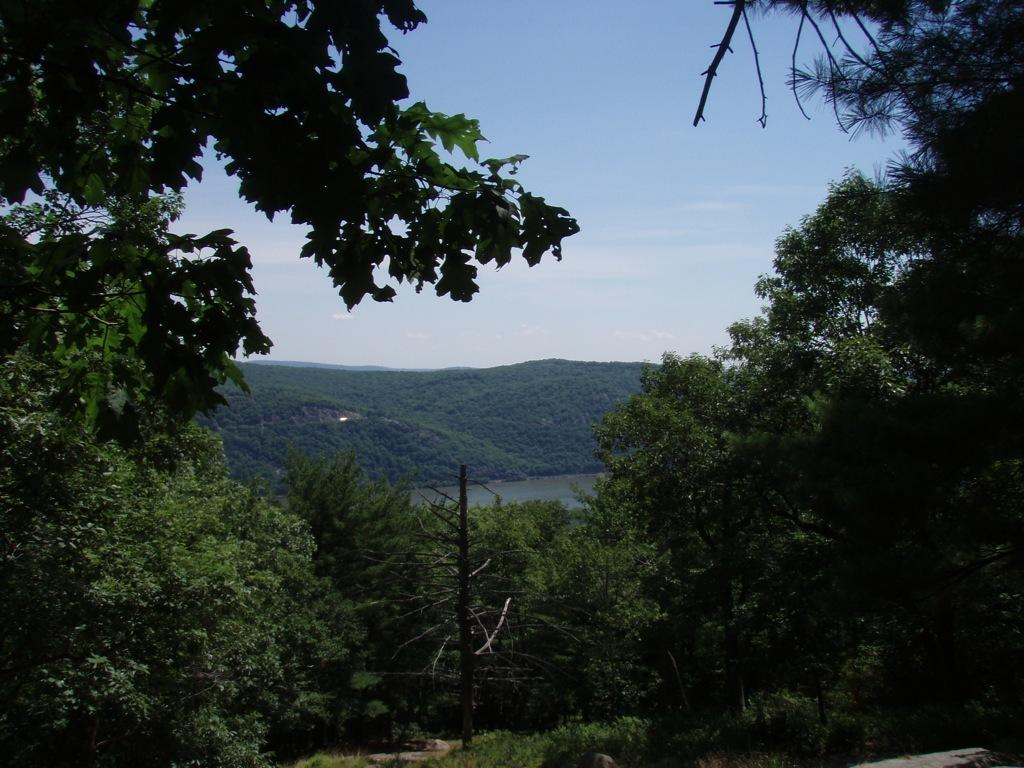What type of vegetation can be seen in the image? There are trees in the image. What part of the natural environment is visible in the image? The sky is visible in the background of the image. What type of honey can be seen dripping from the trees in the image? There is no honey present in the image; it only features trees and the sky. 